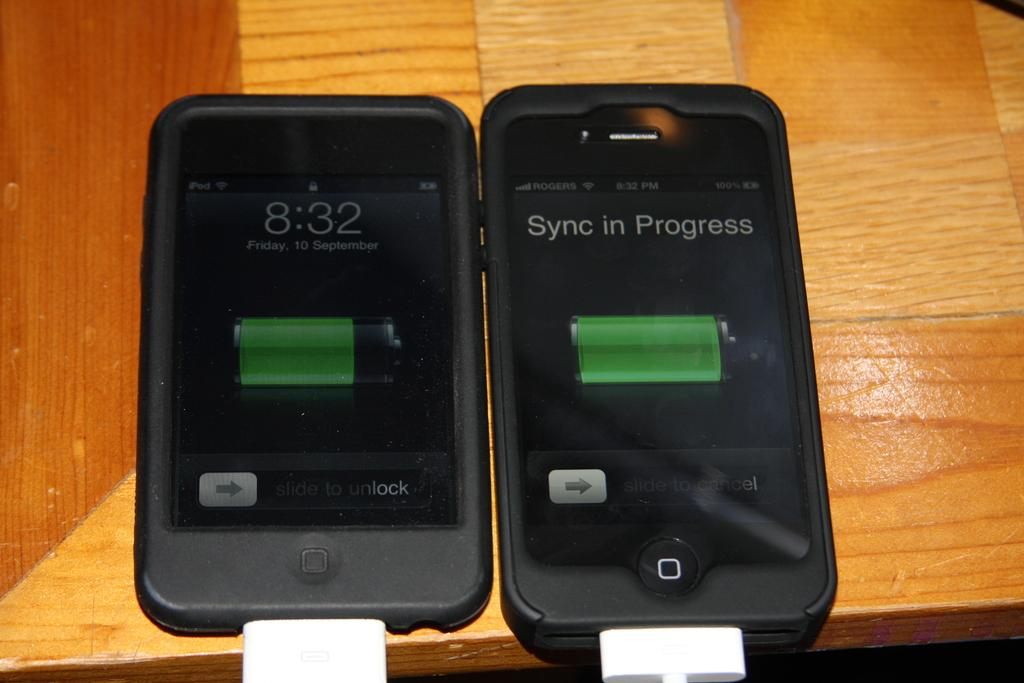Provide a one-sentence caption for the provided image. Two black iphones are lying next to each other while one has a sync in progress. 